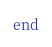<code> <loc_0><loc_0><loc_500><loc_500><_Ruby_>end

</code> 